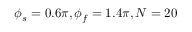<formula> <loc_0><loc_0><loc_500><loc_500>\phi _ { s } = 0 . 6 \pi , \phi _ { f } = 1 . 4 \pi , N = 2 0</formula> 